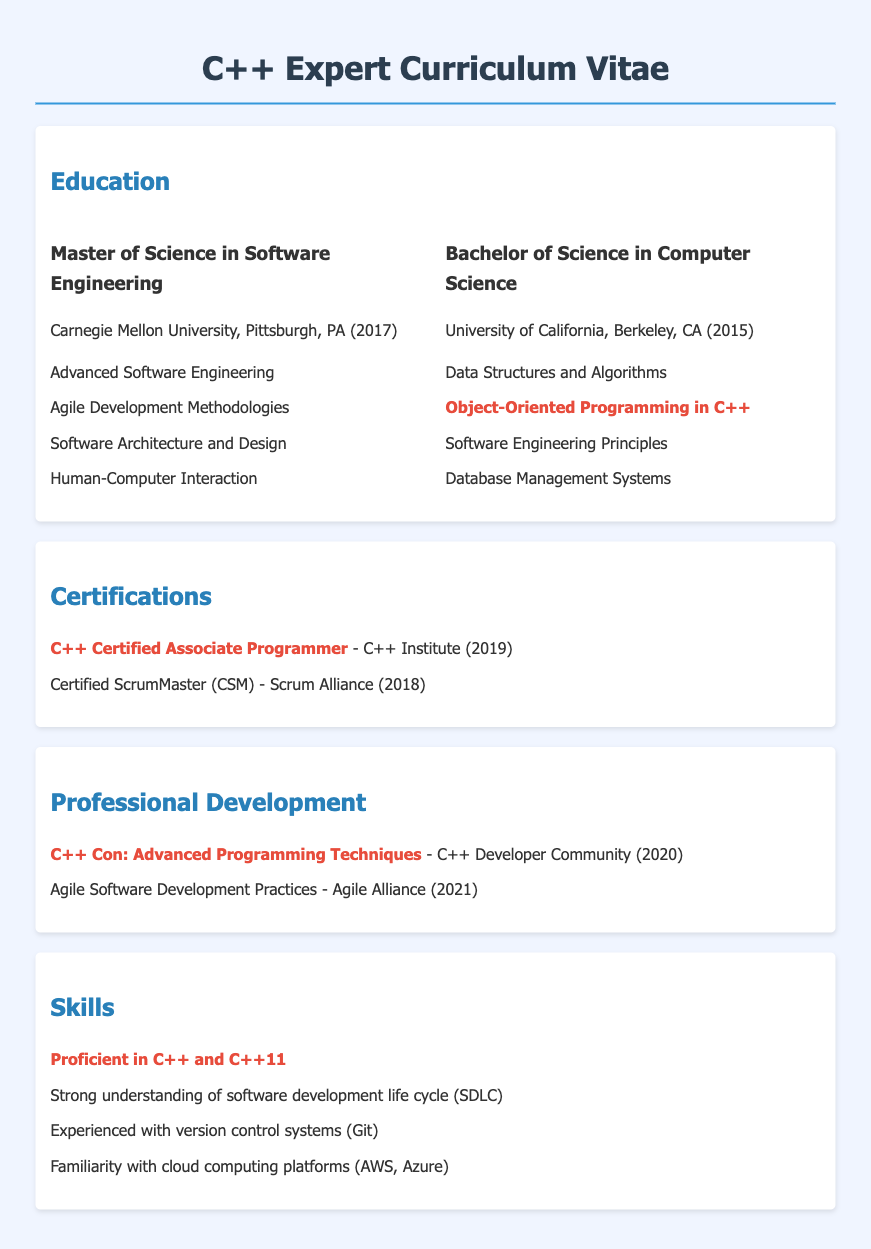What degree did the candidate earn at Carnegie Mellon University? The candidate earned a Master of Science in Software Engineering at Carnegie Mellon University.
Answer: Master of Science in Software Engineering What was the focus of the candidate's Bachelor of Science degree? The focus of the candidate's Bachelor of Science degree was in Computer Science.
Answer: Computer Science In what year did the candidate complete their Bachelor's degree? The document states that the candidate completed their Bachelor's degree in 2015.
Answer: 2015 Which certification did the candidate obtain in 2019? The candidate obtained the C++ Certified Associate Programmer certification in 2019.
Answer: C++ Certified Associate Programmer What is one of the programming languages the candidate is proficient in? The document mentions that the candidate is proficient in C++.
Answer: C++ What was one of the courses taken in the Master's program? One of the courses taken in the Master's program was Agile Development Methodologies.
Answer: Agile Development Methodologies What university did the candidate attend for their undergraduate studies? The candidate attended the University of California, Berkeley for their undergraduate studies.
Answer: University of California, Berkeley Which programming paradigm was highlighted in the Bachelor's coursework? The programming paradigm highlighted in the Bachelor's coursework was Object-Oriented Programming in C++.
Answer: Object-Oriented Programming in C++ What type of educational document is this? The document is a Curriculum Vitae.
Answer: Curriculum Vitae 